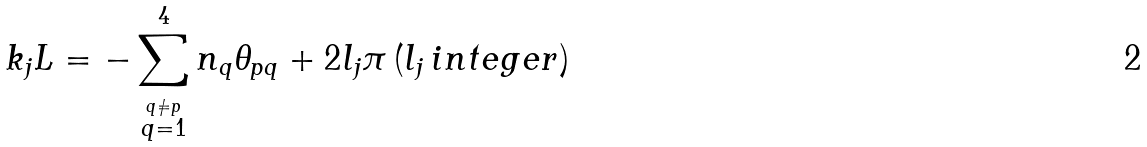Convert formula to latex. <formula><loc_0><loc_0><loc_500><loc_500>k _ { j } L = - \sum _ { \stackrel { q \neq p } { q = 1 } } ^ { 4 } n _ { q } \theta _ { p q } + 2 l _ { j } \pi \, ( l _ { j } \, i n t e g e r )</formula> 